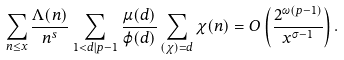<formula> <loc_0><loc_0><loc_500><loc_500>\sum _ { n \leq x } \frac { \Lambda ( n ) } { n ^ { s } } \sum _ { 1 < d | p - 1 } \frac { \mu ( d ) } { \varphi ( d ) } \sum _ { ( \chi ) = d } \chi ( n ) = O \left ( \frac { 2 ^ { \omega ( p - 1 ) } } { x ^ { \sigma - 1 } } \right ) .</formula> 